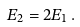<formula> <loc_0><loc_0><loc_500><loc_500>E _ { 2 } = 2 E _ { 1 } \, .</formula> 